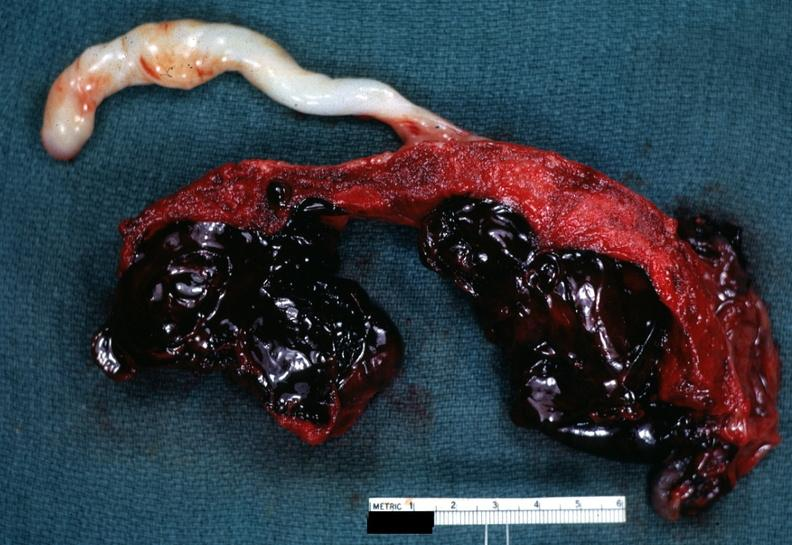what is present?
Answer the question using a single word or phrase. Abruption 